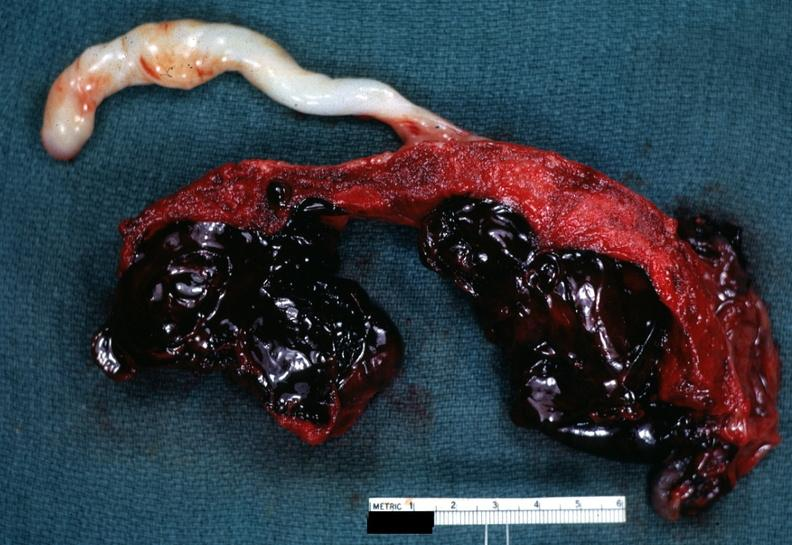what is present?
Answer the question using a single word or phrase. Abruption 